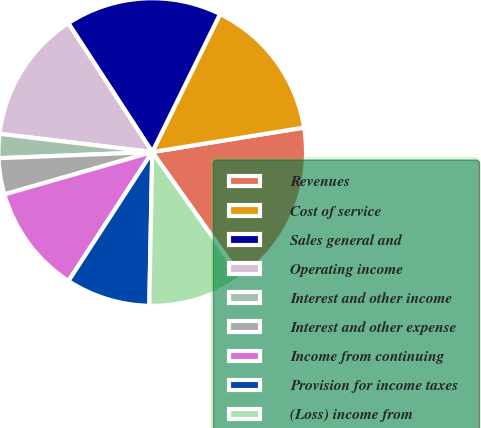Convert chart. <chart><loc_0><loc_0><loc_500><loc_500><pie_chart><fcel>Revenues<fcel>Cost of service<fcel>Sales general and<fcel>Operating income<fcel>Interest and other income<fcel>Interest and other expense<fcel>Income from continuing<fcel>Provision for income taxes<fcel>(Loss) income from<nl><fcel>17.72%<fcel>15.19%<fcel>16.46%<fcel>13.92%<fcel>2.53%<fcel>3.8%<fcel>11.39%<fcel>8.86%<fcel>10.13%<nl></chart> 